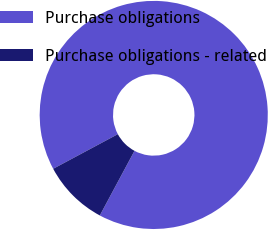<chart> <loc_0><loc_0><loc_500><loc_500><pie_chart><fcel>Purchase obligations<fcel>Purchase obligations - related<nl><fcel>90.66%<fcel>9.34%<nl></chart> 